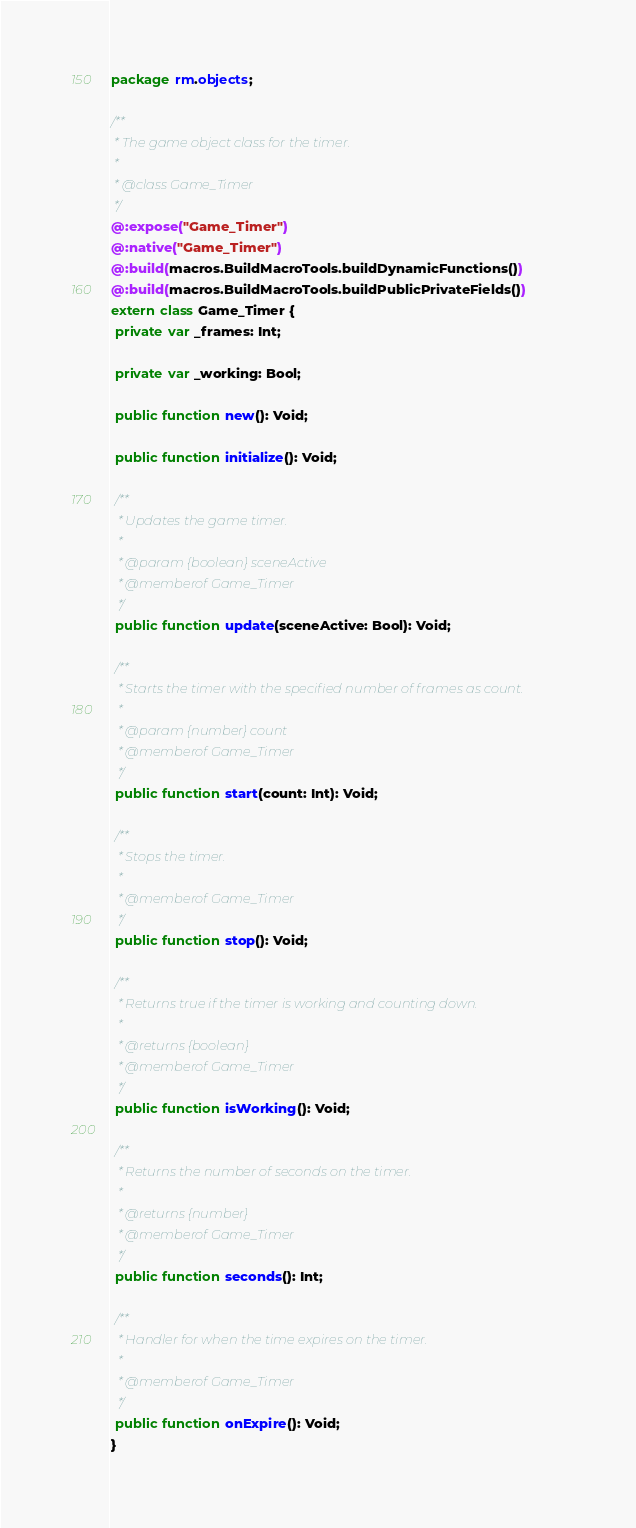<code> <loc_0><loc_0><loc_500><loc_500><_Haxe_>package rm.objects;

/**
 * The game object class for the timer.
 *
 * @class Game_Timer
 */
@:expose("Game_Timer")
@:native("Game_Timer")
@:build(macros.BuildMacroTools.buildDynamicFunctions())
@:build(macros.BuildMacroTools.buildPublicPrivateFields())
extern class Game_Timer {
 private var _frames: Int;

 private var _working: Bool;

 public function new(): Void;

 public function initialize(): Void;

 /**
  * Updates the game timer.
  *
  * @param {boolean} sceneActive
  * @memberof Game_Timer
  */
 public function update(sceneActive: Bool): Void;

 /**
  * Starts the timer with the specified number of frames as count.
  *
  * @param {number} count
  * @memberof Game_Timer
  */
 public function start(count: Int): Void;

 /**
  * Stops the timer.
  *
  * @memberof Game_Timer
  */
 public function stop(): Void;

 /**
  * Returns true if the timer is working and counting down.
  *
  * @returns {boolean}
  * @memberof Game_Timer
  */
 public function isWorking(): Void;

 /**
  * Returns the number of seconds on the timer.
  *
  * @returns {number}
  * @memberof Game_Timer
  */
 public function seconds(): Int;

 /**
  * Handler for when the time expires on the timer.
  *
  * @memberof Game_Timer
  */
 public function onExpire(): Void;
}
</code> 